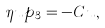<formula> <loc_0><loc_0><loc_500><loc_500>\eta u p _ { 3 } = - C u ,</formula> 